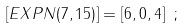Convert formula to latex. <formula><loc_0><loc_0><loc_500><loc_500>\left [ E X P N ( 7 , 1 5 ) \right ] = [ 6 , 0 , 4 ] \ ;</formula> 